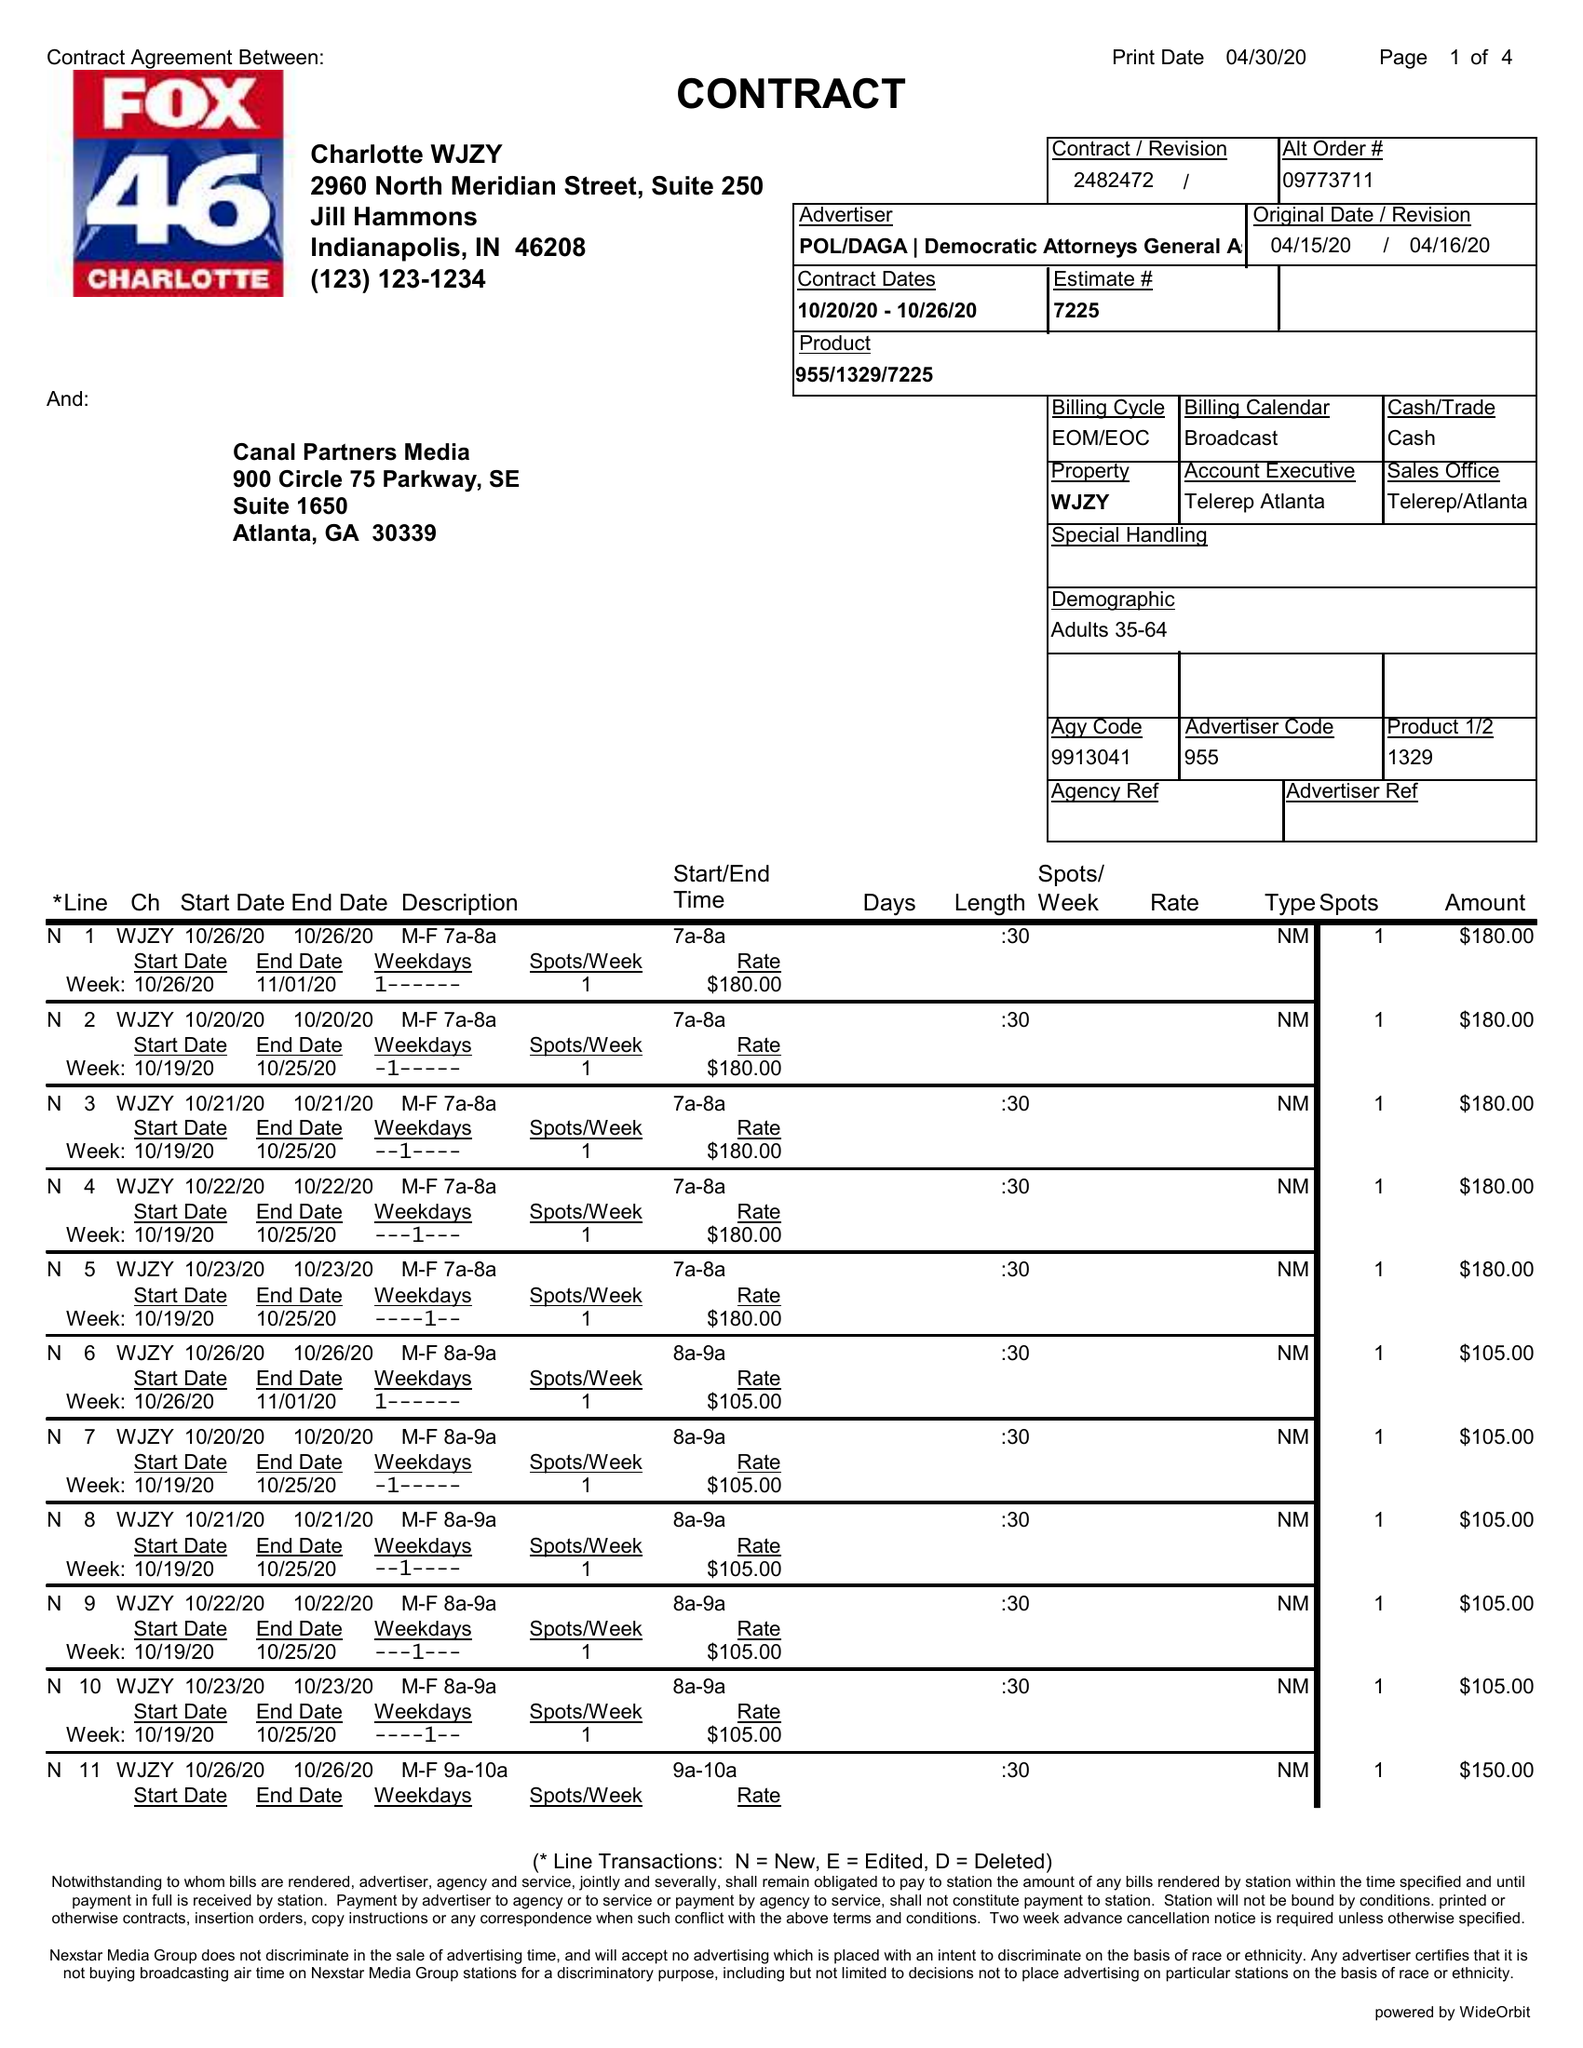What is the value for the contract_num?
Answer the question using a single word or phrase. 2482472 